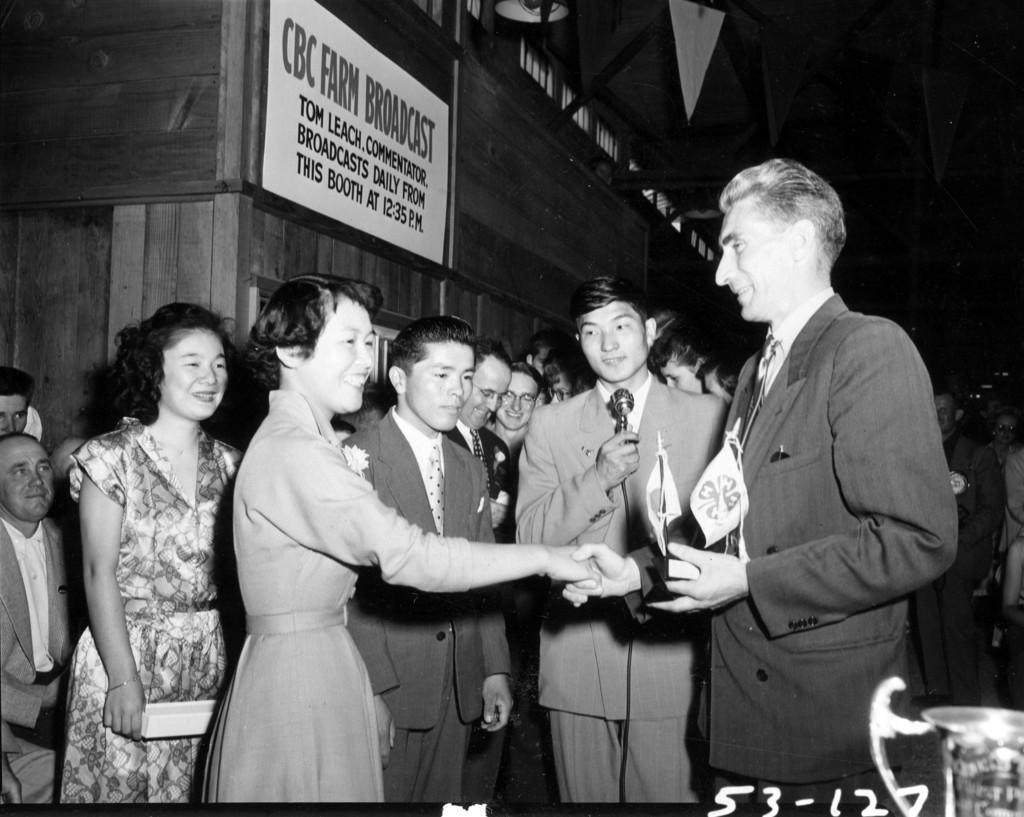In one or two sentences, can you explain what this image depicts? This is a black and white image a man congratulating a woman, in the background there are people and there is wooden wall. 